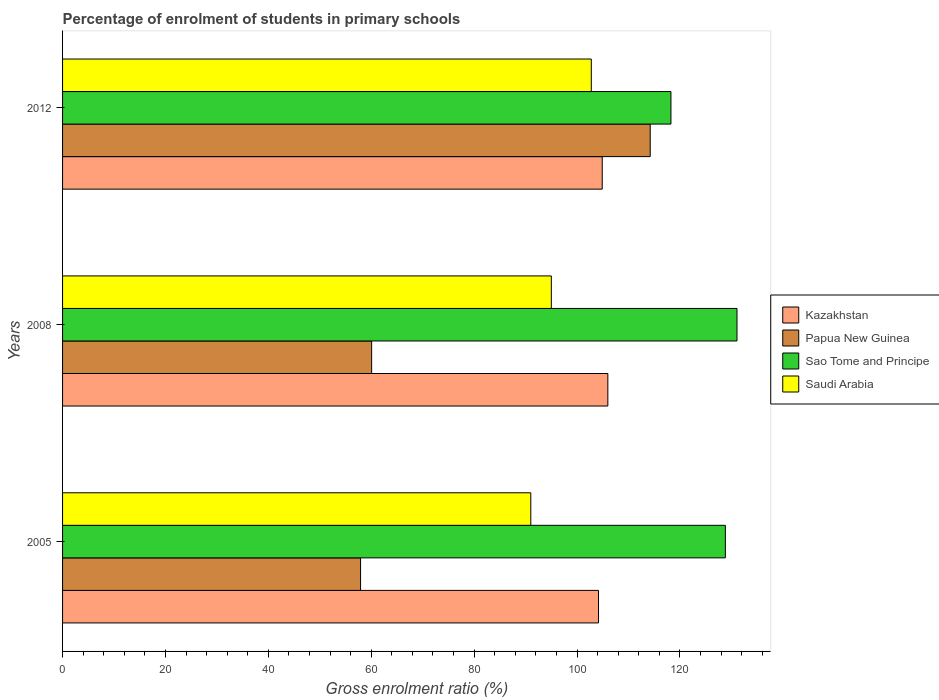How many different coloured bars are there?
Offer a terse response. 4. Are the number of bars on each tick of the Y-axis equal?
Offer a terse response. Yes. How many bars are there on the 3rd tick from the top?
Your response must be concise. 4. How many bars are there on the 3rd tick from the bottom?
Provide a succinct answer. 4. What is the percentage of students enrolled in primary schools in Saudi Arabia in 2012?
Your response must be concise. 102.78. Across all years, what is the maximum percentage of students enrolled in primary schools in Papua New Guinea?
Your response must be concise. 114.23. Across all years, what is the minimum percentage of students enrolled in primary schools in Papua New Guinea?
Give a very brief answer. 57.93. What is the total percentage of students enrolled in primary schools in Papua New Guinea in the graph?
Offer a very short reply. 232.24. What is the difference between the percentage of students enrolled in primary schools in Saudi Arabia in 2005 and that in 2012?
Give a very brief answer. -11.76. What is the difference between the percentage of students enrolled in primary schools in Papua New Guinea in 2008 and the percentage of students enrolled in primary schools in Saudi Arabia in 2012?
Your answer should be compact. -42.7. What is the average percentage of students enrolled in primary schools in Sao Tome and Principe per year?
Provide a short and direct response. 126.07. In the year 2012, what is the difference between the percentage of students enrolled in primary schools in Papua New Guinea and percentage of students enrolled in primary schools in Kazakhstan?
Provide a succinct answer. 9.33. What is the ratio of the percentage of students enrolled in primary schools in Saudi Arabia in 2005 to that in 2012?
Your response must be concise. 0.89. What is the difference between the highest and the second highest percentage of students enrolled in primary schools in Saudi Arabia?
Offer a very short reply. 7.77. What is the difference between the highest and the lowest percentage of students enrolled in primary schools in Sao Tome and Principe?
Your answer should be very brief. 12.84. In how many years, is the percentage of students enrolled in primary schools in Kazakhstan greater than the average percentage of students enrolled in primary schools in Kazakhstan taken over all years?
Make the answer very short. 1. Is it the case that in every year, the sum of the percentage of students enrolled in primary schools in Kazakhstan and percentage of students enrolled in primary schools in Saudi Arabia is greater than the sum of percentage of students enrolled in primary schools in Sao Tome and Principe and percentage of students enrolled in primary schools in Papua New Guinea?
Your answer should be compact. No. What does the 4th bar from the top in 2008 represents?
Your answer should be very brief. Kazakhstan. What does the 2nd bar from the bottom in 2012 represents?
Offer a terse response. Papua New Guinea. How many bars are there?
Give a very brief answer. 12. What is the difference between two consecutive major ticks on the X-axis?
Ensure brevity in your answer.  20. Does the graph contain any zero values?
Give a very brief answer. No. Does the graph contain grids?
Your response must be concise. No. Where does the legend appear in the graph?
Your answer should be compact. Center right. How many legend labels are there?
Provide a short and direct response. 4. What is the title of the graph?
Keep it short and to the point. Percentage of enrolment of students in primary schools. Does "St. Vincent and the Grenadines" appear as one of the legend labels in the graph?
Your answer should be compact. No. What is the label or title of the Y-axis?
Your response must be concise. Years. What is the Gross enrolment ratio (%) of Kazakhstan in 2005?
Offer a very short reply. 104.18. What is the Gross enrolment ratio (%) of Papua New Guinea in 2005?
Offer a very short reply. 57.93. What is the Gross enrolment ratio (%) in Sao Tome and Principe in 2005?
Your answer should be very brief. 128.84. What is the Gross enrolment ratio (%) of Saudi Arabia in 2005?
Ensure brevity in your answer.  91.02. What is the Gross enrolment ratio (%) of Kazakhstan in 2008?
Provide a succinct answer. 105.99. What is the Gross enrolment ratio (%) of Papua New Guinea in 2008?
Provide a succinct answer. 60.08. What is the Gross enrolment ratio (%) in Sao Tome and Principe in 2008?
Your answer should be very brief. 131.1. What is the Gross enrolment ratio (%) of Saudi Arabia in 2008?
Your answer should be very brief. 95.01. What is the Gross enrolment ratio (%) in Kazakhstan in 2012?
Offer a terse response. 104.9. What is the Gross enrolment ratio (%) in Papua New Guinea in 2012?
Offer a terse response. 114.23. What is the Gross enrolment ratio (%) of Sao Tome and Principe in 2012?
Your answer should be compact. 118.26. What is the Gross enrolment ratio (%) in Saudi Arabia in 2012?
Give a very brief answer. 102.78. Across all years, what is the maximum Gross enrolment ratio (%) of Kazakhstan?
Offer a terse response. 105.99. Across all years, what is the maximum Gross enrolment ratio (%) of Papua New Guinea?
Keep it short and to the point. 114.23. Across all years, what is the maximum Gross enrolment ratio (%) of Sao Tome and Principe?
Make the answer very short. 131.1. Across all years, what is the maximum Gross enrolment ratio (%) in Saudi Arabia?
Provide a succinct answer. 102.78. Across all years, what is the minimum Gross enrolment ratio (%) of Kazakhstan?
Provide a short and direct response. 104.18. Across all years, what is the minimum Gross enrolment ratio (%) in Papua New Guinea?
Offer a very short reply. 57.93. Across all years, what is the minimum Gross enrolment ratio (%) of Sao Tome and Principe?
Your answer should be very brief. 118.26. Across all years, what is the minimum Gross enrolment ratio (%) of Saudi Arabia?
Your answer should be very brief. 91.02. What is the total Gross enrolment ratio (%) in Kazakhstan in the graph?
Offer a very short reply. 315.08. What is the total Gross enrolment ratio (%) of Papua New Guinea in the graph?
Offer a very short reply. 232.24. What is the total Gross enrolment ratio (%) of Sao Tome and Principe in the graph?
Keep it short and to the point. 378.2. What is the total Gross enrolment ratio (%) in Saudi Arabia in the graph?
Ensure brevity in your answer.  288.8. What is the difference between the Gross enrolment ratio (%) in Kazakhstan in 2005 and that in 2008?
Offer a terse response. -1.81. What is the difference between the Gross enrolment ratio (%) of Papua New Guinea in 2005 and that in 2008?
Give a very brief answer. -2.15. What is the difference between the Gross enrolment ratio (%) of Sao Tome and Principe in 2005 and that in 2008?
Offer a very short reply. -2.26. What is the difference between the Gross enrolment ratio (%) in Saudi Arabia in 2005 and that in 2008?
Your answer should be compact. -3.99. What is the difference between the Gross enrolment ratio (%) of Kazakhstan in 2005 and that in 2012?
Make the answer very short. -0.72. What is the difference between the Gross enrolment ratio (%) in Papua New Guinea in 2005 and that in 2012?
Offer a terse response. -56.3. What is the difference between the Gross enrolment ratio (%) in Sao Tome and Principe in 2005 and that in 2012?
Provide a short and direct response. 10.58. What is the difference between the Gross enrolment ratio (%) of Saudi Arabia in 2005 and that in 2012?
Provide a succinct answer. -11.76. What is the difference between the Gross enrolment ratio (%) of Kazakhstan in 2008 and that in 2012?
Keep it short and to the point. 1.09. What is the difference between the Gross enrolment ratio (%) in Papua New Guinea in 2008 and that in 2012?
Your answer should be compact. -54.15. What is the difference between the Gross enrolment ratio (%) of Sao Tome and Principe in 2008 and that in 2012?
Offer a very short reply. 12.84. What is the difference between the Gross enrolment ratio (%) of Saudi Arabia in 2008 and that in 2012?
Offer a terse response. -7.77. What is the difference between the Gross enrolment ratio (%) in Kazakhstan in 2005 and the Gross enrolment ratio (%) in Papua New Guinea in 2008?
Provide a short and direct response. 44.1. What is the difference between the Gross enrolment ratio (%) of Kazakhstan in 2005 and the Gross enrolment ratio (%) of Sao Tome and Principe in 2008?
Make the answer very short. -26.92. What is the difference between the Gross enrolment ratio (%) of Kazakhstan in 2005 and the Gross enrolment ratio (%) of Saudi Arabia in 2008?
Ensure brevity in your answer.  9.17. What is the difference between the Gross enrolment ratio (%) of Papua New Guinea in 2005 and the Gross enrolment ratio (%) of Sao Tome and Principe in 2008?
Offer a very short reply. -73.17. What is the difference between the Gross enrolment ratio (%) in Papua New Guinea in 2005 and the Gross enrolment ratio (%) in Saudi Arabia in 2008?
Make the answer very short. -37.08. What is the difference between the Gross enrolment ratio (%) of Sao Tome and Principe in 2005 and the Gross enrolment ratio (%) of Saudi Arabia in 2008?
Your answer should be very brief. 33.83. What is the difference between the Gross enrolment ratio (%) in Kazakhstan in 2005 and the Gross enrolment ratio (%) in Papua New Guinea in 2012?
Your answer should be very brief. -10.05. What is the difference between the Gross enrolment ratio (%) in Kazakhstan in 2005 and the Gross enrolment ratio (%) in Sao Tome and Principe in 2012?
Your answer should be very brief. -14.08. What is the difference between the Gross enrolment ratio (%) of Kazakhstan in 2005 and the Gross enrolment ratio (%) of Saudi Arabia in 2012?
Your answer should be compact. 1.4. What is the difference between the Gross enrolment ratio (%) of Papua New Guinea in 2005 and the Gross enrolment ratio (%) of Sao Tome and Principe in 2012?
Keep it short and to the point. -60.33. What is the difference between the Gross enrolment ratio (%) of Papua New Guinea in 2005 and the Gross enrolment ratio (%) of Saudi Arabia in 2012?
Provide a short and direct response. -44.85. What is the difference between the Gross enrolment ratio (%) of Sao Tome and Principe in 2005 and the Gross enrolment ratio (%) of Saudi Arabia in 2012?
Give a very brief answer. 26.06. What is the difference between the Gross enrolment ratio (%) of Kazakhstan in 2008 and the Gross enrolment ratio (%) of Papua New Guinea in 2012?
Give a very brief answer. -8.24. What is the difference between the Gross enrolment ratio (%) of Kazakhstan in 2008 and the Gross enrolment ratio (%) of Sao Tome and Principe in 2012?
Offer a terse response. -12.26. What is the difference between the Gross enrolment ratio (%) in Kazakhstan in 2008 and the Gross enrolment ratio (%) in Saudi Arabia in 2012?
Keep it short and to the point. 3.22. What is the difference between the Gross enrolment ratio (%) in Papua New Guinea in 2008 and the Gross enrolment ratio (%) in Sao Tome and Principe in 2012?
Provide a short and direct response. -58.18. What is the difference between the Gross enrolment ratio (%) in Papua New Guinea in 2008 and the Gross enrolment ratio (%) in Saudi Arabia in 2012?
Your answer should be compact. -42.7. What is the difference between the Gross enrolment ratio (%) in Sao Tome and Principe in 2008 and the Gross enrolment ratio (%) in Saudi Arabia in 2012?
Provide a short and direct response. 28.32. What is the average Gross enrolment ratio (%) in Kazakhstan per year?
Keep it short and to the point. 105.03. What is the average Gross enrolment ratio (%) of Papua New Guinea per year?
Your answer should be compact. 77.41. What is the average Gross enrolment ratio (%) in Sao Tome and Principe per year?
Offer a terse response. 126.07. What is the average Gross enrolment ratio (%) in Saudi Arabia per year?
Your answer should be compact. 96.27. In the year 2005, what is the difference between the Gross enrolment ratio (%) of Kazakhstan and Gross enrolment ratio (%) of Papua New Guinea?
Ensure brevity in your answer.  46.25. In the year 2005, what is the difference between the Gross enrolment ratio (%) in Kazakhstan and Gross enrolment ratio (%) in Sao Tome and Principe?
Your response must be concise. -24.66. In the year 2005, what is the difference between the Gross enrolment ratio (%) of Kazakhstan and Gross enrolment ratio (%) of Saudi Arabia?
Make the answer very short. 13.16. In the year 2005, what is the difference between the Gross enrolment ratio (%) of Papua New Guinea and Gross enrolment ratio (%) of Sao Tome and Principe?
Your answer should be very brief. -70.91. In the year 2005, what is the difference between the Gross enrolment ratio (%) of Papua New Guinea and Gross enrolment ratio (%) of Saudi Arabia?
Ensure brevity in your answer.  -33.09. In the year 2005, what is the difference between the Gross enrolment ratio (%) in Sao Tome and Principe and Gross enrolment ratio (%) in Saudi Arabia?
Make the answer very short. 37.82. In the year 2008, what is the difference between the Gross enrolment ratio (%) in Kazakhstan and Gross enrolment ratio (%) in Papua New Guinea?
Make the answer very short. 45.92. In the year 2008, what is the difference between the Gross enrolment ratio (%) in Kazakhstan and Gross enrolment ratio (%) in Sao Tome and Principe?
Provide a short and direct response. -25.11. In the year 2008, what is the difference between the Gross enrolment ratio (%) of Kazakhstan and Gross enrolment ratio (%) of Saudi Arabia?
Provide a short and direct response. 10.99. In the year 2008, what is the difference between the Gross enrolment ratio (%) of Papua New Guinea and Gross enrolment ratio (%) of Sao Tome and Principe?
Make the answer very short. -71.02. In the year 2008, what is the difference between the Gross enrolment ratio (%) of Papua New Guinea and Gross enrolment ratio (%) of Saudi Arabia?
Make the answer very short. -34.93. In the year 2008, what is the difference between the Gross enrolment ratio (%) in Sao Tome and Principe and Gross enrolment ratio (%) in Saudi Arabia?
Keep it short and to the point. 36.09. In the year 2012, what is the difference between the Gross enrolment ratio (%) in Kazakhstan and Gross enrolment ratio (%) in Papua New Guinea?
Your answer should be very brief. -9.33. In the year 2012, what is the difference between the Gross enrolment ratio (%) in Kazakhstan and Gross enrolment ratio (%) in Sao Tome and Principe?
Your response must be concise. -13.36. In the year 2012, what is the difference between the Gross enrolment ratio (%) in Kazakhstan and Gross enrolment ratio (%) in Saudi Arabia?
Ensure brevity in your answer.  2.12. In the year 2012, what is the difference between the Gross enrolment ratio (%) of Papua New Guinea and Gross enrolment ratio (%) of Sao Tome and Principe?
Provide a short and direct response. -4.03. In the year 2012, what is the difference between the Gross enrolment ratio (%) in Papua New Guinea and Gross enrolment ratio (%) in Saudi Arabia?
Your response must be concise. 11.45. In the year 2012, what is the difference between the Gross enrolment ratio (%) in Sao Tome and Principe and Gross enrolment ratio (%) in Saudi Arabia?
Your answer should be very brief. 15.48. What is the ratio of the Gross enrolment ratio (%) in Kazakhstan in 2005 to that in 2008?
Offer a very short reply. 0.98. What is the ratio of the Gross enrolment ratio (%) of Papua New Guinea in 2005 to that in 2008?
Your response must be concise. 0.96. What is the ratio of the Gross enrolment ratio (%) of Sao Tome and Principe in 2005 to that in 2008?
Offer a very short reply. 0.98. What is the ratio of the Gross enrolment ratio (%) in Saudi Arabia in 2005 to that in 2008?
Keep it short and to the point. 0.96. What is the ratio of the Gross enrolment ratio (%) of Papua New Guinea in 2005 to that in 2012?
Offer a terse response. 0.51. What is the ratio of the Gross enrolment ratio (%) of Sao Tome and Principe in 2005 to that in 2012?
Your response must be concise. 1.09. What is the ratio of the Gross enrolment ratio (%) in Saudi Arabia in 2005 to that in 2012?
Keep it short and to the point. 0.89. What is the ratio of the Gross enrolment ratio (%) of Kazakhstan in 2008 to that in 2012?
Your answer should be compact. 1.01. What is the ratio of the Gross enrolment ratio (%) of Papua New Guinea in 2008 to that in 2012?
Provide a short and direct response. 0.53. What is the ratio of the Gross enrolment ratio (%) of Sao Tome and Principe in 2008 to that in 2012?
Your answer should be compact. 1.11. What is the ratio of the Gross enrolment ratio (%) in Saudi Arabia in 2008 to that in 2012?
Provide a short and direct response. 0.92. What is the difference between the highest and the second highest Gross enrolment ratio (%) in Kazakhstan?
Provide a succinct answer. 1.09. What is the difference between the highest and the second highest Gross enrolment ratio (%) of Papua New Guinea?
Your answer should be compact. 54.15. What is the difference between the highest and the second highest Gross enrolment ratio (%) of Sao Tome and Principe?
Provide a succinct answer. 2.26. What is the difference between the highest and the second highest Gross enrolment ratio (%) of Saudi Arabia?
Your answer should be compact. 7.77. What is the difference between the highest and the lowest Gross enrolment ratio (%) of Kazakhstan?
Ensure brevity in your answer.  1.81. What is the difference between the highest and the lowest Gross enrolment ratio (%) in Papua New Guinea?
Offer a terse response. 56.3. What is the difference between the highest and the lowest Gross enrolment ratio (%) of Sao Tome and Principe?
Provide a succinct answer. 12.84. What is the difference between the highest and the lowest Gross enrolment ratio (%) in Saudi Arabia?
Keep it short and to the point. 11.76. 